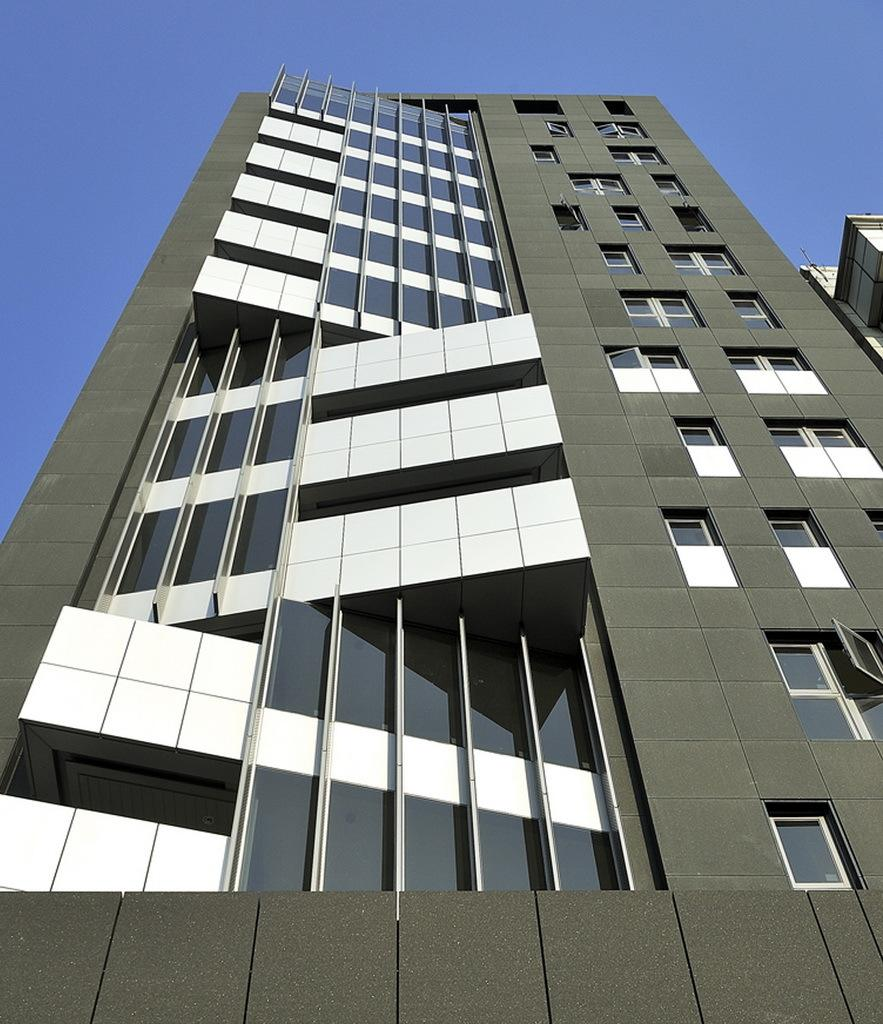What is the main subject of the image? The main subject of the image is a building. What specific features can be observed on the building? The building has windows. What can be seen in the background of the image? The sky is visible in the background of the image. What type of coach is parked in front of the building in the image? There is no coach present in the image; it only features a building with windows and a visible sky in the background. 